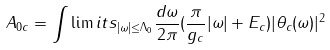Convert formula to latex. <formula><loc_0><loc_0><loc_500><loc_500>A _ { 0 c } = \int \lim i t s _ { | \omega | \leq \Lambda _ { 0 } } { \frac { d \omega } { 2 \pi } } ( { \frac { \pi } { g _ { c } } } | \omega | + E _ { c } ) | \theta _ { c } ( \omega ) | ^ { 2 }</formula> 